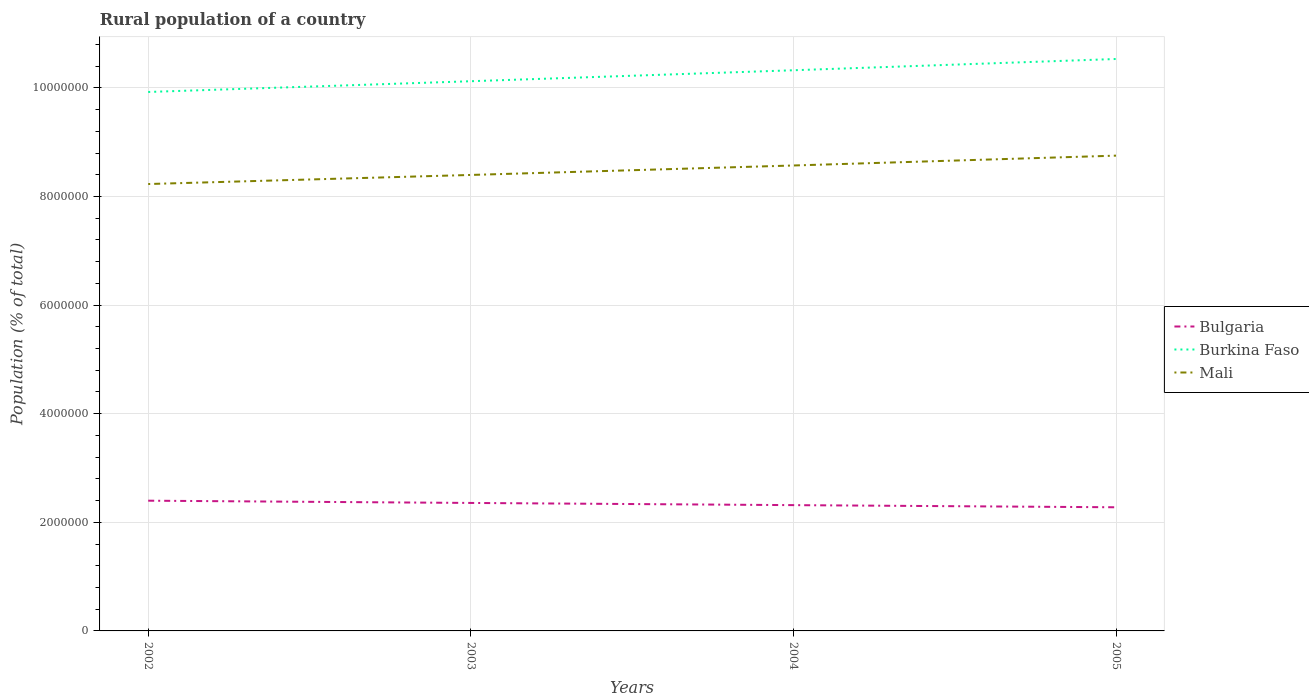How many different coloured lines are there?
Your response must be concise. 3. Does the line corresponding to Bulgaria intersect with the line corresponding to Burkina Faso?
Your answer should be compact. No. Across all years, what is the maximum rural population in Mali?
Provide a short and direct response. 8.23e+06. In which year was the rural population in Burkina Faso maximum?
Your response must be concise. 2002. What is the total rural population in Bulgaria in the graph?
Give a very brief answer. 7.98e+04. What is the difference between the highest and the second highest rural population in Mali?
Your answer should be very brief. 5.23e+05. What is the difference between the highest and the lowest rural population in Bulgaria?
Give a very brief answer. 2. Is the rural population in Burkina Faso strictly greater than the rural population in Bulgaria over the years?
Your response must be concise. No. How many lines are there?
Your response must be concise. 3. What is the difference between two consecutive major ticks on the Y-axis?
Your answer should be compact. 2.00e+06. Does the graph contain grids?
Make the answer very short. Yes. How many legend labels are there?
Your response must be concise. 3. How are the legend labels stacked?
Make the answer very short. Vertical. What is the title of the graph?
Ensure brevity in your answer.  Rural population of a country. Does "Aruba" appear as one of the legend labels in the graph?
Your answer should be compact. No. What is the label or title of the Y-axis?
Your answer should be very brief. Population (% of total). What is the Population (% of total) of Bulgaria in 2002?
Offer a terse response. 2.40e+06. What is the Population (% of total) of Burkina Faso in 2002?
Offer a very short reply. 9.92e+06. What is the Population (% of total) in Mali in 2002?
Provide a succinct answer. 8.23e+06. What is the Population (% of total) of Bulgaria in 2003?
Provide a succinct answer. 2.36e+06. What is the Population (% of total) of Burkina Faso in 2003?
Ensure brevity in your answer.  1.01e+07. What is the Population (% of total) of Mali in 2003?
Give a very brief answer. 8.40e+06. What is the Population (% of total) in Bulgaria in 2004?
Your answer should be compact. 2.32e+06. What is the Population (% of total) of Burkina Faso in 2004?
Your response must be concise. 1.03e+07. What is the Population (% of total) of Mali in 2004?
Your answer should be very brief. 8.57e+06. What is the Population (% of total) in Bulgaria in 2005?
Your answer should be compact. 2.28e+06. What is the Population (% of total) in Burkina Faso in 2005?
Ensure brevity in your answer.  1.05e+07. What is the Population (% of total) in Mali in 2005?
Offer a very short reply. 8.75e+06. Across all years, what is the maximum Population (% of total) in Bulgaria?
Your answer should be compact. 2.40e+06. Across all years, what is the maximum Population (% of total) of Burkina Faso?
Keep it short and to the point. 1.05e+07. Across all years, what is the maximum Population (% of total) of Mali?
Make the answer very short. 8.75e+06. Across all years, what is the minimum Population (% of total) of Bulgaria?
Keep it short and to the point. 2.28e+06. Across all years, what is the minimum Population (% of total) in Burkina Faso?
Your answer should be very brief. 9.92e+06. Across all years, what is the minimum Population (% of total) in Mali?
Keep it short and to the point. 8.23e+06. What is the total Population (% of total) of Bulgaria in the graph?
Your answer should be very brief. 9.35e+06. What is the total Population (% of total) in Burkina Faso in the graph?
Provide a succinct answer. 4.09e+07. What is the total Population (% of total) in Mali in the graph?
Provide a short and direct response. 3.39e+07. What is the difference between the Population (% of total) in Bulgaria in 2002 and that in 2003?
Your response must be concise. 4.15e+04. What is the difference between the Population (% of total) of Burkina Faso in 2002 and that in 2003?
Offer a very short reply. -1.98e+05. What is the difference between the Population (% of total) in Mali in 2002 and that in 2003?
Your answer should be compact. -1.67e+05. What is the difference between the Population (% of total) in Bulgaria in 2002 and that in 2004?
Offer a very short reply. 8.18e+04. What is the difference between the Population (% of total) in Burkina Faso in 2002 and that in 2004?
Give a very brief answer. -4.00e+05. What is the difference between the Population (% of total) in Mali in 2002 and that in 2004?
Keep it short and to the point. -3.41e+05. What is the difference between the Population (% of total) in Bulgaria in 2002 and that in 2005?
Provide a succinct answer. 1.21e+05. What is the difference between the Population (% of total) of Burkina Faso in 2002 and that in 2005?
Your answer should be compact. -6.07e+05. What is the difference between the Population (% of total) in Mali in 2002 and that in 2005?
Provide a short and direct response. -5.23e+05. What is the difference between the Population (% of total) of Bulgaria in 2003 and that in 2004?
Make the answer very short. 4.03e+04. What is the difference between the Population (% of total) in Burkina Faso in 2003 and that in 2004?
Your response must be concise. -2.02e+05. What is the difference between the Population (% of total) in Mali in 2003 and that in 2004?
Provide a succinct answer. -1.74e+05. What is the difference between the Population (% of total) of Bulgaria in 2003 and that in 2005?
Your answer should be very brief. 7.98e+04. What is the difference between the Population (% of total) in Burkina Faso in 2003 and that in 2005?
Give a very brief answer. -4.09e+05. What is the difference between the Population (% of total) in Mali in 2003 and that in 2005?
Make the answer very short. -3.56e+05. What is the difference between the Population (% of total) of Bulgaria in 2004 and that in 2005?
Your answer should be compact. 3.94e+04. What is the difference between the Population (% of total) of Burkina Faso in 2004 and that in 2005?
Make the answer very short. -2.07e+05. What is the difference between the Population (% of total) in Mali in 2004 and that in 2005?
Offer a terse response. -1.81e+05. What is the difference between the Population (% of total) in Bulgaria in 2002 and the Population (% of total) in Burkina Faso in 2003?
Give a very brief answer. -7.72e+06. What is the difference between the Population (% of total) of Bulgaria in 2002 and the Population (% of total) of Mali in 2003?
Your answer should be compact. -6.00e+06. What is the difference between the Population (% of total) of Burkina Faso in 2002 and the Population (% of total) of Mali in 2003?
Keep it short and to the point. 1.53e+06. What is the difference between the Population (% of total) of Bulgaria in 2002 and the Population (% of total) of Burkina Faso in 2004?
Offer a very short reply. -7.93e+06. What is the difference between the Population (% of total) in Bulgaria in 2002 and the Population (% of total) in Mali in 2004?
Offer a very short reply. -6.17e+06. What is the difference between the Population (% of total) of Burkina Faso in 2002 and the Population (% of total) of Mali in 2004?
Provide a succinct answer. 1.35e+06. What is the difference between the Population (% of total) in Bulgaria in 2002 and the Population (% of total) in Burkina Faso in 2005?
Offer a terse response. -8.13e+06. What is the difference between the Population (% of total) of Bulgaria in 2002 and the Population (% of total) of Mali in 2005?
Make the answer very short. -6.35e+06. What is the difference between the Population (% of total) in Burkina Faso in 2002 and the Population (% of total) in Mali in 2005?
Make the answer very short. 1.17e+06. What is the difference between the Population (% of total) of Bulgaria in 2003 and the Population (% of total) of Burkina Faso in 2004?
Offer a terse response. -7.97e+06. What is the difference between the Population (% of total) of Bulgaria in 2003 and the Population (% of total) of Mali in 2004?
Your answer should be very brief. -6.21e+06. What is the difference between the Population (% of total) of Burkina Faso in 2003 and the Population (% of total) of Mali in 2004?
Make the answer very short. 1.55e+06. What is the difference between the Population (% of total) of Bulgaria in 2003 and the Population (% of total) of Burkina Faso in 2005?
Ensure brevity in your answer.  -8.17e+06. What is the difference between the Population (% of total) in Bulgaria in 2003 and the Population (% of total) in Mali in 2005?
Offer a very short reply. -6.40e+06. What is the difference between the Population (% of total) of Burkina Faso in 2003 and the Population (% of total) of Mali in 2005?
Your answer should be very brief. 1.37e+06. What is the difference between the Population (% of total) of Bulgaria in 2004 and the Population (% of total) of Burkina Faso in 2005?
Make the answer very short. -8.22e+06. What is the difference between the Population (% of total) of Bulgaria in 2004 and the Population (% of total) of Mali in 2005?
Provide a short and direct response. -6.44e+06. What is the difference between the Population (% of total) of Burkina Faso in 2004 and the Population (% of total) of Mali in 2005?
Make the answer very short. 1.57e+06. What is the average Population (% of total) of Bulgaria per year?
Provide a succinct answer. 2.34e+06. What is the average Population (% of total) in Burkina Faso per year?
Give a very brief answer. 1.02e+07. What is the average Population (% of total) in Mali per year?
Ensure brevity in your answer.  8.49e+06. In the year 2002, what is the difference between the Population (% of total) of Bulgaria and Population (% of total) of Burkina Faso?
Provide a succinct answer. -7.53e+06. In the year 2002, what is the difference between the Population (% of total) of Bulgaria and Population (% of total) of Mali?
Provide a succinct answer. -5.83e+06. In the year 2002, what is the difference between the Population (% of total) in Burkina Faso and Population (% of total) in Mali?
Your response must be concise. 1.70e+06. In the year 2003, what is the difference between the Population (% of total) of Bulgaria and Population (% of total) of Burkina Faso?
Your answer should be compact. -7.77e+06. In the year 2003, what is the difference between the Population (% of total) in Bulgaria and Population (% of total) in Mali?
Your answer should be compact. -6.04e+06. In the year 2003, what is the difference between the Population (% of total) in Burkina Faso and Population (% of total) in Mali?
Your answer should be compact. 1.73e+06. In the year 2004, what is the difference between the Population (% of total) of Bulgaria and Population (% of total) of Burkina Faso?
Your response must be concise. -8.01e+06. In the year 2004, what is the difference between the Population (% of total) in Bulgaria and Population (% of total) in Mali?
Give a very brief answer. -6.25e+06. In the year 2004, what is the difference between the Population (% of total) of Burkina Faso and Population (% of total) of Mali?
Provide a succinct answer. 1.75e+06. In the year 2005, what is the difference between the Population (% of total) in Bulgaria and Population (% of total) in Burkina Faso?
Provide a short and direct response. -8.25e+06. In the year 2005, what is the difference between the Population (% of total) in Bulgaria and Population (% of total) in Mali?
Make the answer very short. -6.47e+06. In the year 2005, what is the difference between the Population (% of total) of Burkina Faso and Population (% of total) of Mali?
Keep it short and to the point. 1.78e+06. What is the ratio of the Population (% of total) in Bulgaria in 2002 to that in 2003?
Your response must be concise. 1.02. What is the ratio of the Population (% of total) of Burkina Faso in 2002 to that in 2003?
Your answer should be very brief. 0.98. What is the ratio of the Population (% of total) in Mali in 2002 to that in 2003?
Give a very brief answer. 0.98. What is the ratio of the Population (% of total) of Bulgaria in 2002 to that in 2004?
Ensure brevity in your answer.  1.04. What is the ratio of the Population (% of total) of Burkina Faso in 2002 to that in 2004?
Your response must be concise. 0.96. What is the ratio of the Population (% of total) of Mali in 2002 to that in 2004?
Give a very brief answer. 0.96. What is the ratio of the Population (% of total) in Bulgaria in 2002 to that in 2005?
Your response must be concise. 1.05. What is the ratio of the Population (% of total) in Burkina Faso in 2002 to that in 2005?
Provide a short and direct response. 0.94. What is the ratio of the Population (% of total) in Mali in 2002 to that in 2005?
Offer a terse response. 0.94. What is the ratio of the Population (% of total) in Bulgaria in 2003 to that in 2004?
Make the answer very short. 1.02. What is the ratio of the Population (% of total) in Burkina Faso in 2003 to that in 2004?
Your answer should be very brief. 0.98. What is the ratio of the Population (% of total) in Mali in 2003 to that in 2004?
Your answer should be compact. 0.98. What is the ratio of the Population (% of total) of Bulgaria in 2003 to that in 2005?
Make the answer very short. 1.03. What is the ratio of the Population (% of total) in Burkina Faso in 2003 to that in 2005?
Ensure brevity in your answer.  0.96. What is the ratio of the Population (% of total) in Mali in 2003 to that in 2005?
Offer a terse response. 0.96. What is the ratio of the Population (% of total) in Bulgaria in 2004 to that in 2005?
Your answer should be compact. 1.02. What is the ratio of the Population (% of total) in Burkina Faso in 2004 to that in 2005?
Offer a very short reply. 0.98. What is the ratio of the Population (% of total) in Mali in 2004 to that in 2005?
Provide a short and direct response. 0.98. What is the difference between the highest and the second highest Population (% of total) in Bulgaria?
Offer a very short reply. 4.15e+04. What is the difference between the highest and the second highest Population (% of total) in Burkina Faso?
Provide a short and direct response. 2.07e+05. What is the difference between the highest and the second highest Population (% of total) of Mali?
Ensure brevity in your answer.  1.81e+05. What is the difference between the highest and the lowest Population (% of total) of Bulgaria?
Provide a succinct answer. 1.21e+05. What is the difference between the highest and the lowest Population (% of total) of Burkina Faso?
Provide a short and direct response. 6.07e+05. What is the difference between the highest and the lowest Population (% of total) of Mali?
Offer a very short reply. 5.23e+05. 